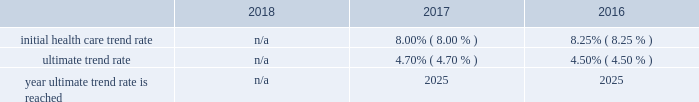Marathon oil corporation notes to consolidated financial statements expected long-term return on plan assets 2013 the expected long-term return on plan assets assumption for our u.s .
Funded plan is determined based on an asset rate-of-return modeling tool developed by a third-party investment group which utilizes underlying assumptions based on actual returns by asset category and inflation and takes into account our u.s .
Pension plan 2019s asset allocation .
To determine the expected long-term return on plan assets assumption for our international plans , we consider the current level of expected returns on risk-free investments ( primarily government bonds ) , the historical levels of the risk premiums associated with the other applicable asset categories and the expectations for future returns of each asset class .
The expected return for each asset category is then weighted based on the actual asset allocation to develop the overall expected long-term return on plan assets assumption .
Assumed weighted average health care cost trend rates .
N/a all retiree medical subsidies are frozen as of january 1 , 2019 .
Employer provided subsidies for post-65 retiree health care coverage were frozen effective january 1 , 2017 at january 1 , 2016 established amount levels .
Company contributions are funded to a health reimbursement account on the retiree 2019s behalf to subsidize the retiree 2019s cost of obtaining health care benefits through a private exchange ( the 201cpost-65 retiree health benefits 201d ) .
Therefore , a 1% ( 1 % ) change in health care cost trend rates would not have a material impact on either the service and interest cost components and the postretirement benefit obligations .
In the fourth quarter of 2018 , we terminated the post-65 retiree health benefits effective as of december 31 , 2020 .
The post-65 retiree health benefits will no longer be provided after that date .
In addition , the pre-65 retiree medical coverage subsidy has been frozen as of january 1 , 2019 , and the ability for retirees to opt in and out of this coverage , as well as pre-65 retiree dental and vision coverage , has also been eliminated .
Retirees must enroll in connection with retirement for such coverage , or they lose eligibility .
These plan changes reduced our retiree medical benefit obligation by approximately $ 99 million .
Plan investment policies and strategies 2013 the investment policies for our u.s .
And international pension plan assets reflect the funded status of the plans and expectations regarding our future ability to make further contributions .
Long-term investment goals are to : ( 1 ) manage the assets in accordance with applicable legal requirements ; ( 2 ) produce investment returns which meet or exceed the rates of return achievable in the capital markets while maintaining the risk parameters set by the plan's investment committees and protecting the assets from any erosion of purchasing power ; and ( 3 ) position the portfolios with a long-term risk/ return orientation .
Investment performance and risk is measured and monitored on an ongoing basis through quarterly investment meetings and periodic asset and liability studies .
U.s .
Plan 2013 the plan 2019s current targeted asset allocation is comprised of 55% ( 55 % ) equity securities and 45% ( 45 % ) other fixed income securities .
Over time , as the plan 2019s funded ratio ( as defined by the investment policy ) improves , in order to reduce volatility in returns and to better match the plan 2019s liabilities , the allocation to equity securities will decrease while the amount allocated to fixed income securities will increase .
The plan's assets are managed by a third-party investment manager .
International plan 2013 our international plan's target asset allocation is comprised of 55% ( 55 % ) equity securities and 45% ( 45 % ) fixed income securities .
The plan assets are invested in ten separate portfolios , mainly pooled fund vehicles , managed by several professional investment managers whose performance is measured independently by a third-party asset servicing consulting fair value measurements 2013 plan assets are measured at fair value .
The following provides a description of the valuation techniques employed for each major plan asset class at december 31 , 2018 and 2017 .
Cash and cash equivalents 2013 cash and cash equivalents are valued using a market approach and are considered level 1 .
Equity securities 2013 investments in common stock are valued using a market approach at the closing price reported in an active market and are therefore considered level 1 .
Private equity investments include interests in limited partnerships which are valued based on the sum of the estimated fair values of the investments held by each partnership , determined using a combination of market , income and cost approaches , plus working capital , adjusted for liabilities , currency translation and estimated performance incentives .
These private equity investments are considered level 3 .
Investments in pooled funds are valued using a market approach , these various funds consist of equity with underlying investments held in u.s .
And non-u.s .
Securities .
The pooled funds are benchmarked against a relative public index and are considered level 2. .
Was the ultimate trend rate greater in 2017 than in 2016? 
Computations: (4.70 > 4.50)
Answer: yes. 